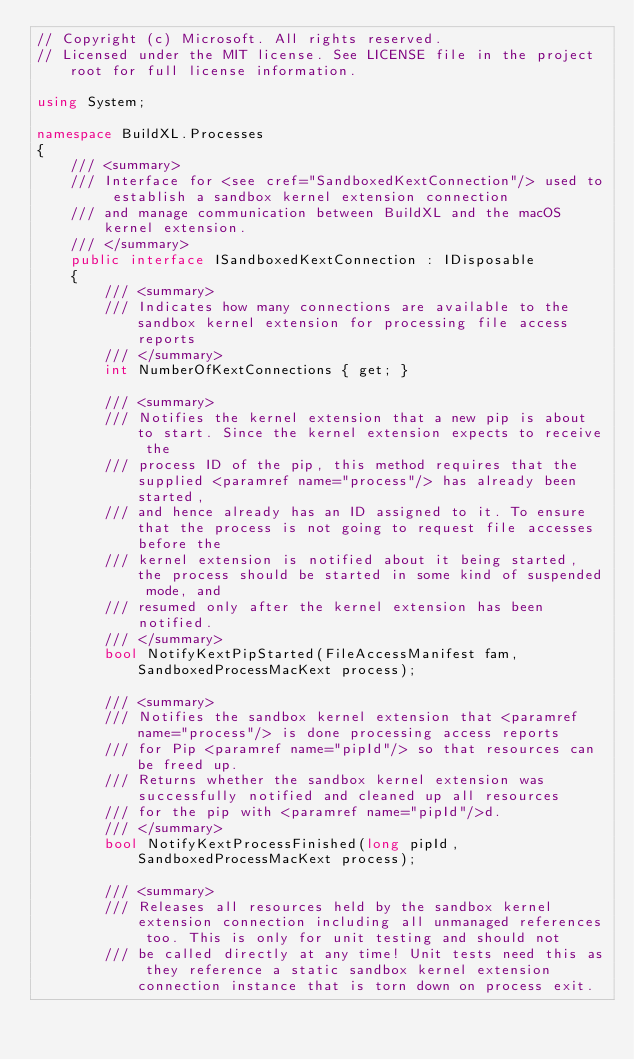<code> <loc_0><loc_0><loc_500><loc_500><_C#_>// Copyright (c) Microsoft. All rights reserved.
// Licensed under the MIT license. See LICENSE file in the project root for full license information.

using System;

namespace BuildXL.Processes
{
    /// <summary>
    /// Interface for <see cref="SandboxedKextConnection"/> used to establish a sandbox kernel extension connection
    /// and manage communication between BuildXL and the macOS kernel extension.
    /// </summary>
    public interface ISandboxedKextConnection : IDisposable
    {
        /// <summary>
        /// Indicates how many connections are available to the sandbox kernel extension for processing file access reports
        /// </summary>
        int NumberOfKextConnections { get; }

        /// <summary>
        /// Notifies the kernel extension that a new pip is about to start. Since the kernel extension expects to receive the
        /// process ID of the pip, this method requires that the supplied <paramref name="process"/> has already been started,
        /// and hence already has an ID assigned to it. To ensure that the process is not going to request file accesses before the
        /// kernel extension is notified about it being started, the process should be started in some kind of suspended mode, and
        /// resumed only after the kernel extension has been notified.
        /// </summary>
        bool NotifyKextPipStarted(FileAccessManifest fam, SandboxedProcessMacKext process);

        /// <summary>
        /// Notifies the sandbox kernel extension that <paramref name="process"/> is done processing access reports
        /// for Pip <paramref name="pipId"/> so that resources can be freed up.
        /// Returns whether the sandbox kernel extension was successfully notified and cleaned up all resources
        /// for the pip with <paramref name="pipId"/>d.
        /// </summary>
        bool NotifyKextProcessFinished(long pipId, SandboxedProcessMacKext process);

        /// <summary>
        /// Releases all resources held by the sandbox kernel extension connection including all unmanaged references too. This is only for unit testing and should not
        /// be called directly at any time! Unit tests need this as they reference a static sandbox kernel extension connection instance that is torn down on process exit.</code> 